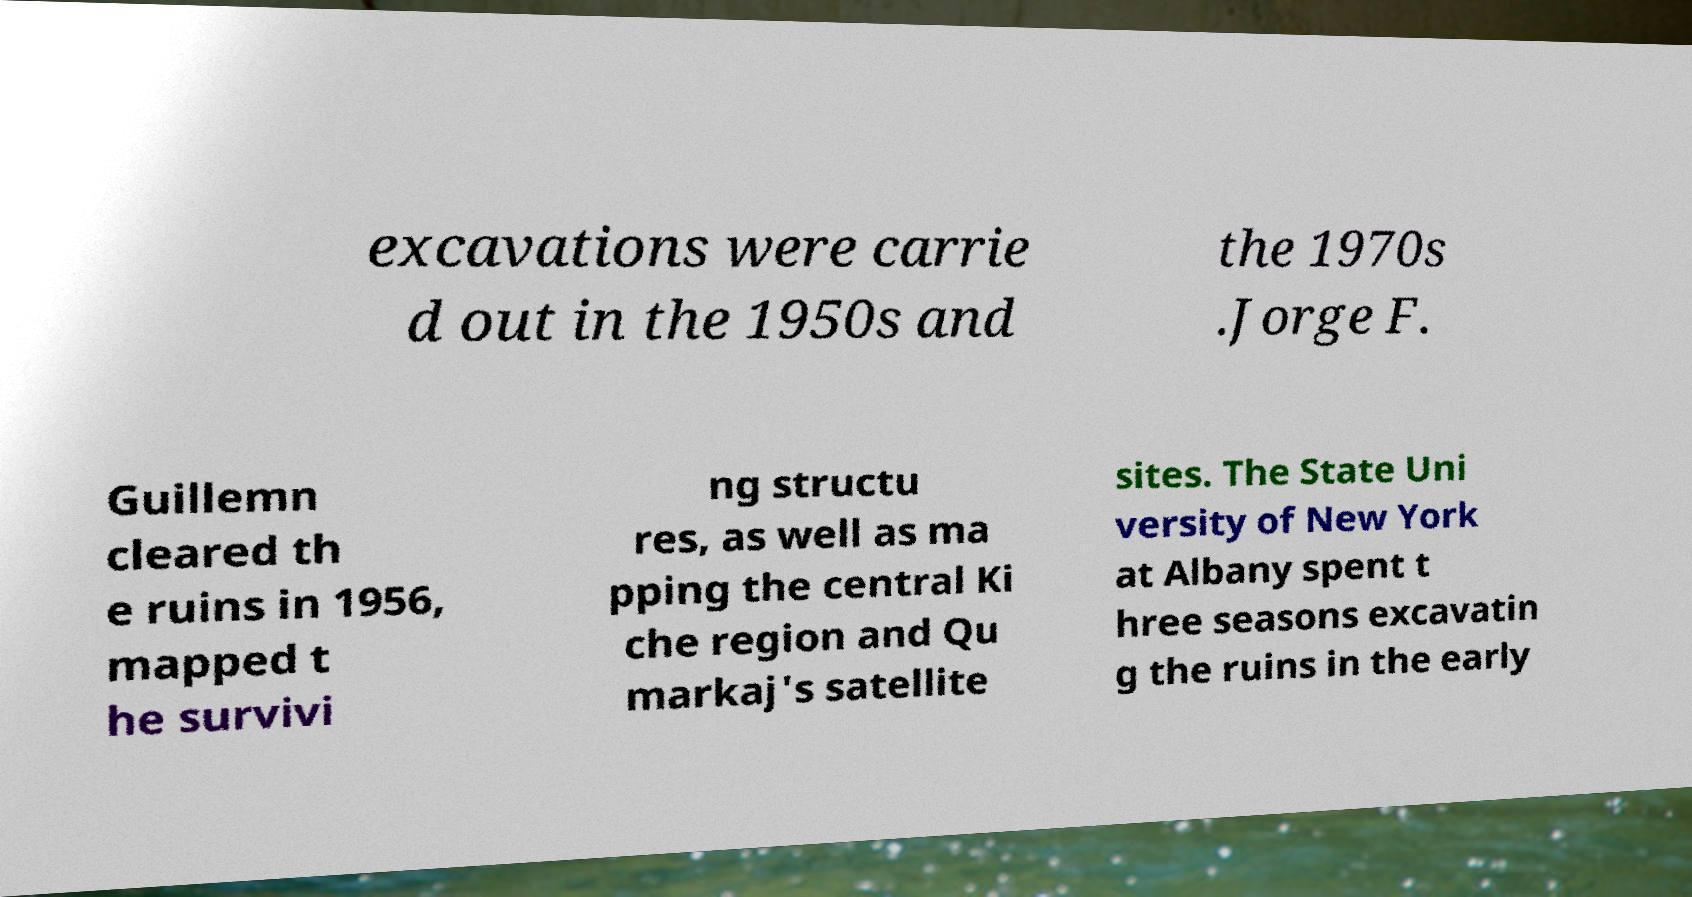I need the written content from this picture converted into text. Can you do that? excavations were carrie d out in the 1950s and the 1970s .Jorge F. Guillemn cleared th e ruins in 1956, mapped t he survivi ng structu res, as well as ma pping the central Ki che region and Qu markaj's satellite sites. The State Uni versity of New York at Albany spent t hree seasons excavatin g the ruins in the early 